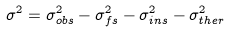<formula> <loc_0><loc_0><loc_500><loc_500>\sigma ^ { 2 } = \sigma _ { o b s } ^ { 2 } - \sigma _ { f s } ^ { 2 } - \sigma _ { i n s } ^ { 2 } - \sigma _ { t h e r } ^ { 2 }</formula> 